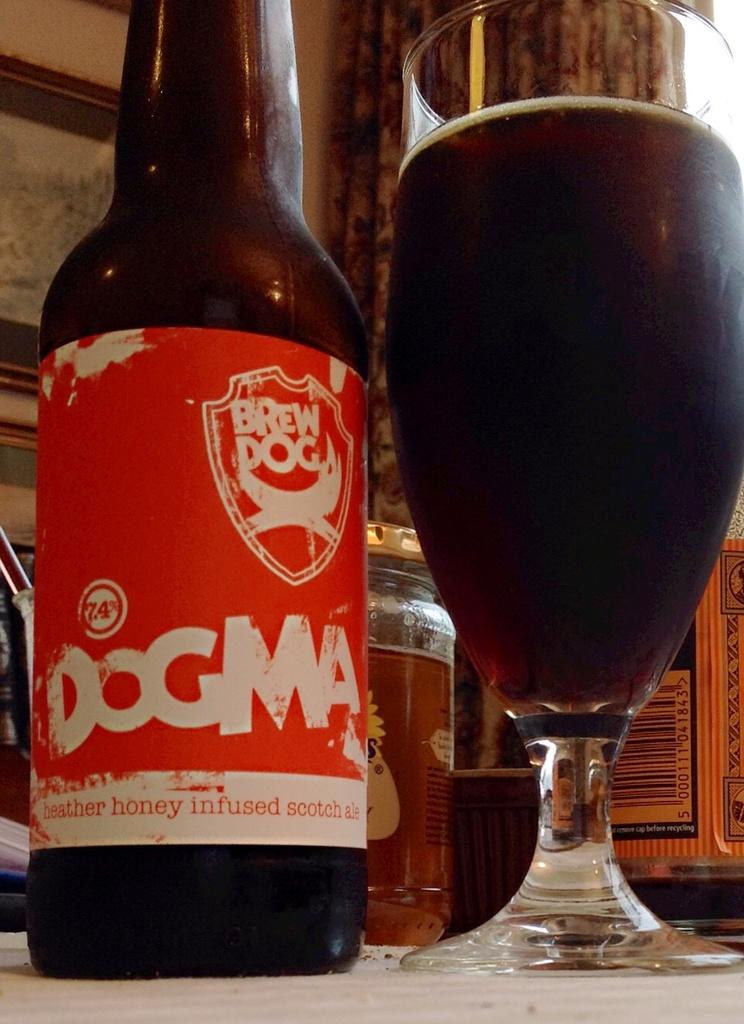Provide a one-sentence caption for the provided image. A bottle and glass of Dogma Brew beer sitting together. 